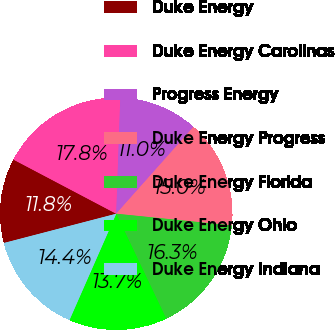<chart> <loc_0><loc_0><loc_500><loc_500><pie_chart><fcel>Duke Energy<fcel>Duke Energy Carolinas<fcel>Progress Energy<fcel>Duke Energy Progress<fcel>Duke Energy Florida<fcel>Duke Energy Ohio<fcel>Duke Energy Indiana<nl><fcel>11.77%<fcel>17.84%<fcel>11.01%<fcel>15.03%<fcel>16.32%<fcel>13.67%<fcel>14.35%<nl></chart> 